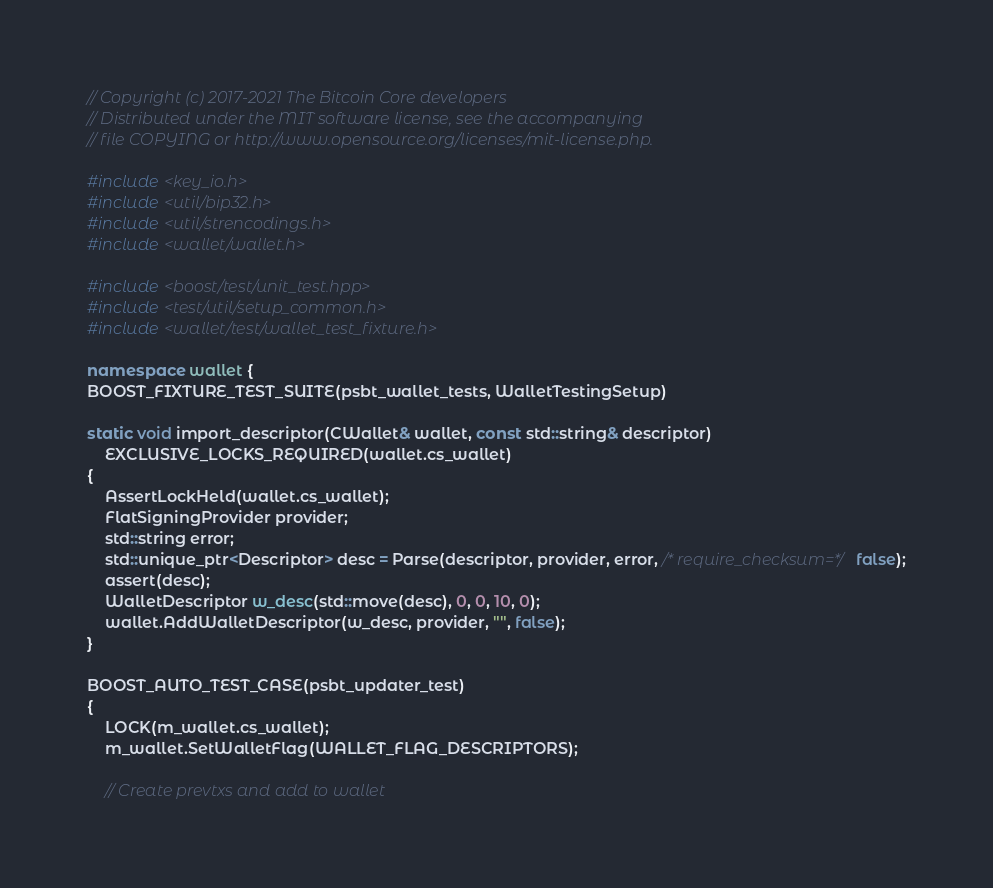Convert code to text. <code><loc_0><loc_0><loc_500><loc_500><_C++_>// Copyright (c) 2017-2021 The Bitcoin Core developers
// Distributed under the MIT software license, see the accompanying
// file COPYING or http://www.opensource.org/licenses/mit-license.php.

#include <key_io.h>
#include <util/bip32.h>
#include <util/strencodings.h>
#include <wallet/wallet.h>

#include <boost/test/unit_test.hpp>
#include <test/util/setup_common.h>
#include <wallet/test/wallet_test_fixture.h>

namespace wallet {
BOOST_FIXTURE_TEST_SUITE(psbt_wallet_tests, WalletTestingSetup)

static void import_descriptor(CWallet& wallet, const std::string& descriptor)
    EXCLUSIVE_LOCKS_REQUIRED(wallet.cs_wallet)
{
    AssertLockHeld(wallet.cs_wallet);
    FlatSigningProvider provider;
    std::string error;
    std::unique_ptr<Descriptor> desc = Parse(descriptor, provider, error, /* require_checksum=*/ false);
    assert(desc);
    WalletDescriptor w_desc(std::move(desc), 0, 0, 10, 0);
    wallet.AddWalletDescriptor(w_desc, provider, "", false);
}

BOOST_AUTO_TEST_CASE(psbt_updater_test)
{
    LOCK(m_wallet.cs_wallet);
    m_wallet.SetWalletFlag(WALLET_FLAG_DESCRIPTORS);

    // Create prevtxs and add to wallet</code> 